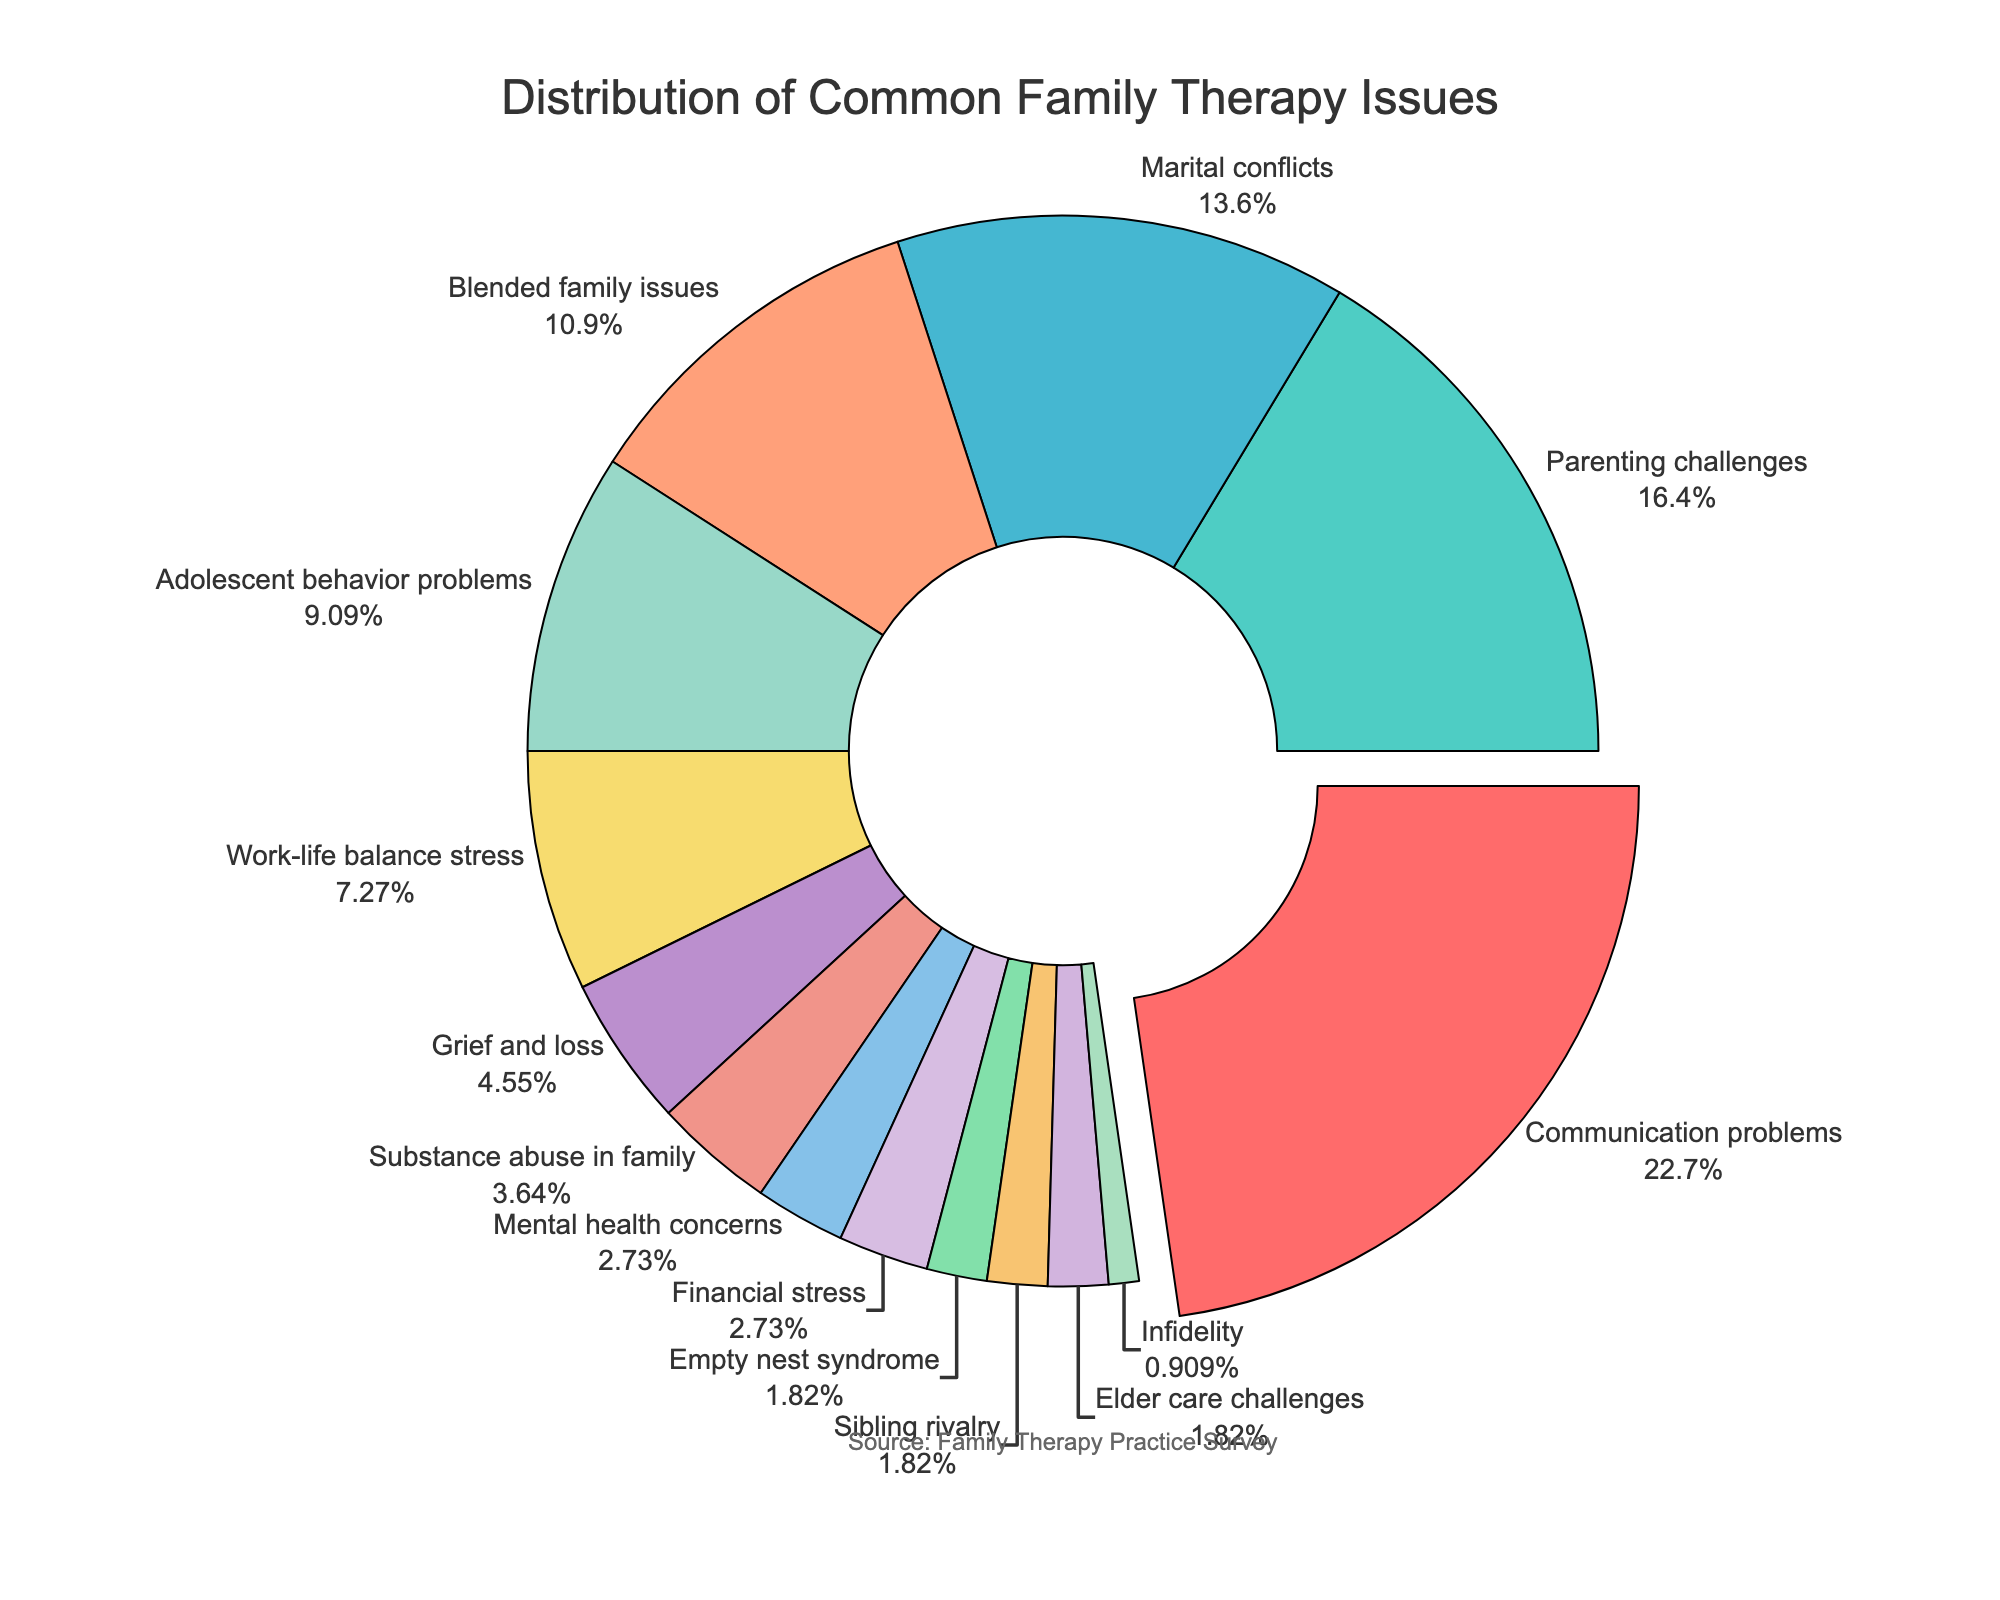What is the most common family therapy issue addressed in practice? The pie chart shows the distribution of common family therapy issues. The largest segment, occupying 25% of the pie chart, is labeled "Communication problems."
Answer: Communication problems What is the combined percentage of Parenting challenges and Marital conflicts? The pie chart segments for "Parenting challenges" and "Marital conflicts" together have percentages of 18% and 15%, respectively. Adding these values gives 18 + 15 = 33.
Answer: 33% Which issue has twice the percentage of Adolescent behavior problems? The segment labeled "Communication problems" has a percentage of 25%. The segment labeled "Adolescent behavior problems" has 10%. By visual comparison, 25% is more than twice the percentage of 10%.
Answer: Communication problems How many issues have a percentage that is 5% or lower? By looking at the pie chart, the issues with 5% or lower are: Grief and loss (5%), Substance abuse in family (4%), Mental health concerns (3%), Financial stress (3%), Empty nest syndrome (2%), Sibling rivalry (2%), Elder care challenges (2%), and Infidelity (1%). Counting them gives us a total of 8 issues.
Answer: 8 Is Work-life balance stress more significant than Adolescent behavior problems? The pie chart shows Work-life balance stress with 8% and Adolescent behavior problems with 10%. Since 8% is less than 10%, Work-life balance stress is not more significant.
Answer: No What is the difference in percentage between the least common issue and the most common issue? The most common issue has a percentage of 25% (Communication problems), and the least common issue has 1% (Infidelity). The difference is calculated as 25 - 1 = 24.
Answer: 24% Are there any issues with the same percentage? By examining the pie chart, issues with the same percentage are Empty nest syndrome, Sibling rivalry, and Elder care challenges, each with 2%. Additionally, Mental health concerns and Financial stress both have 3%.
Answer: Yes Which visual segment has the smallest size, and what issue does it represent? The segment with the smallest size on the pie chart represents the issue "Infidelity," which has a percentage of 1%.
Answer: Infidelity What is the average percentage of Financial stress, Mental health concerns, and Substance abuse in family? The percentages for Financial stress, Mental health concerns, and Substance abuse in family are 3%, 3%, and 4%, respectively. Adding these gives 3 + 3 + 4 = 10, and the average is 10 / 3 ≈ 3.33.
Answer: 3.33% 